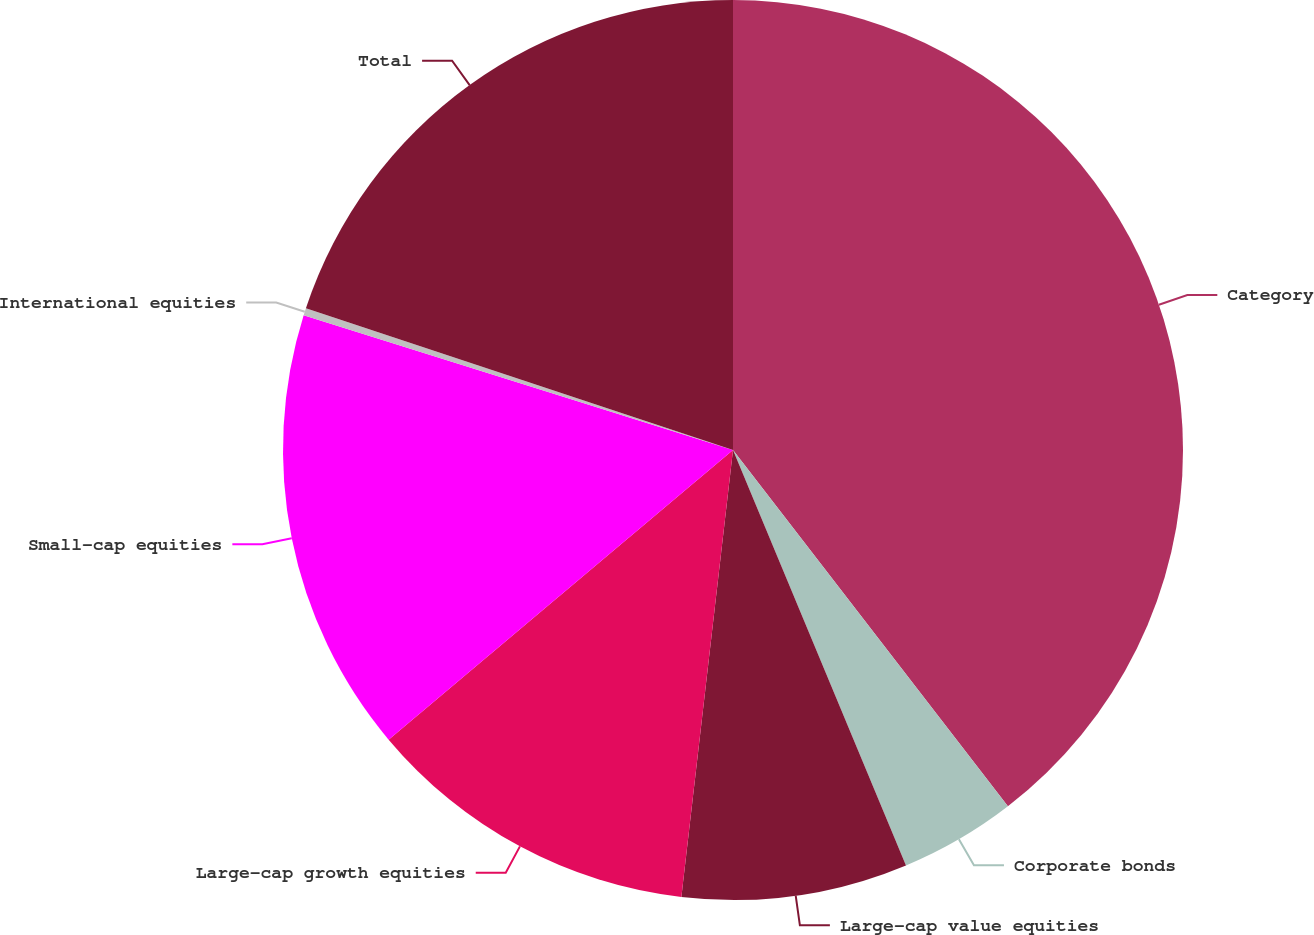Convert chart. <chart><loc_0><loc_0><loc_500><loc_500><pie_chart><fcel>Category<fcel>Corporate bonds<fcel>Large-cap value equities<fcel>Large-cap growth equities<fcel>Small-cap equities<fcel>International equities<fcel>Total<nl><fcel>39.54%<fcel>4.18%<fcel>8.11%<fcel>12.04%<fcel>15.97%<fcel>0.26%<fcel>19.9%<nl></chart> 